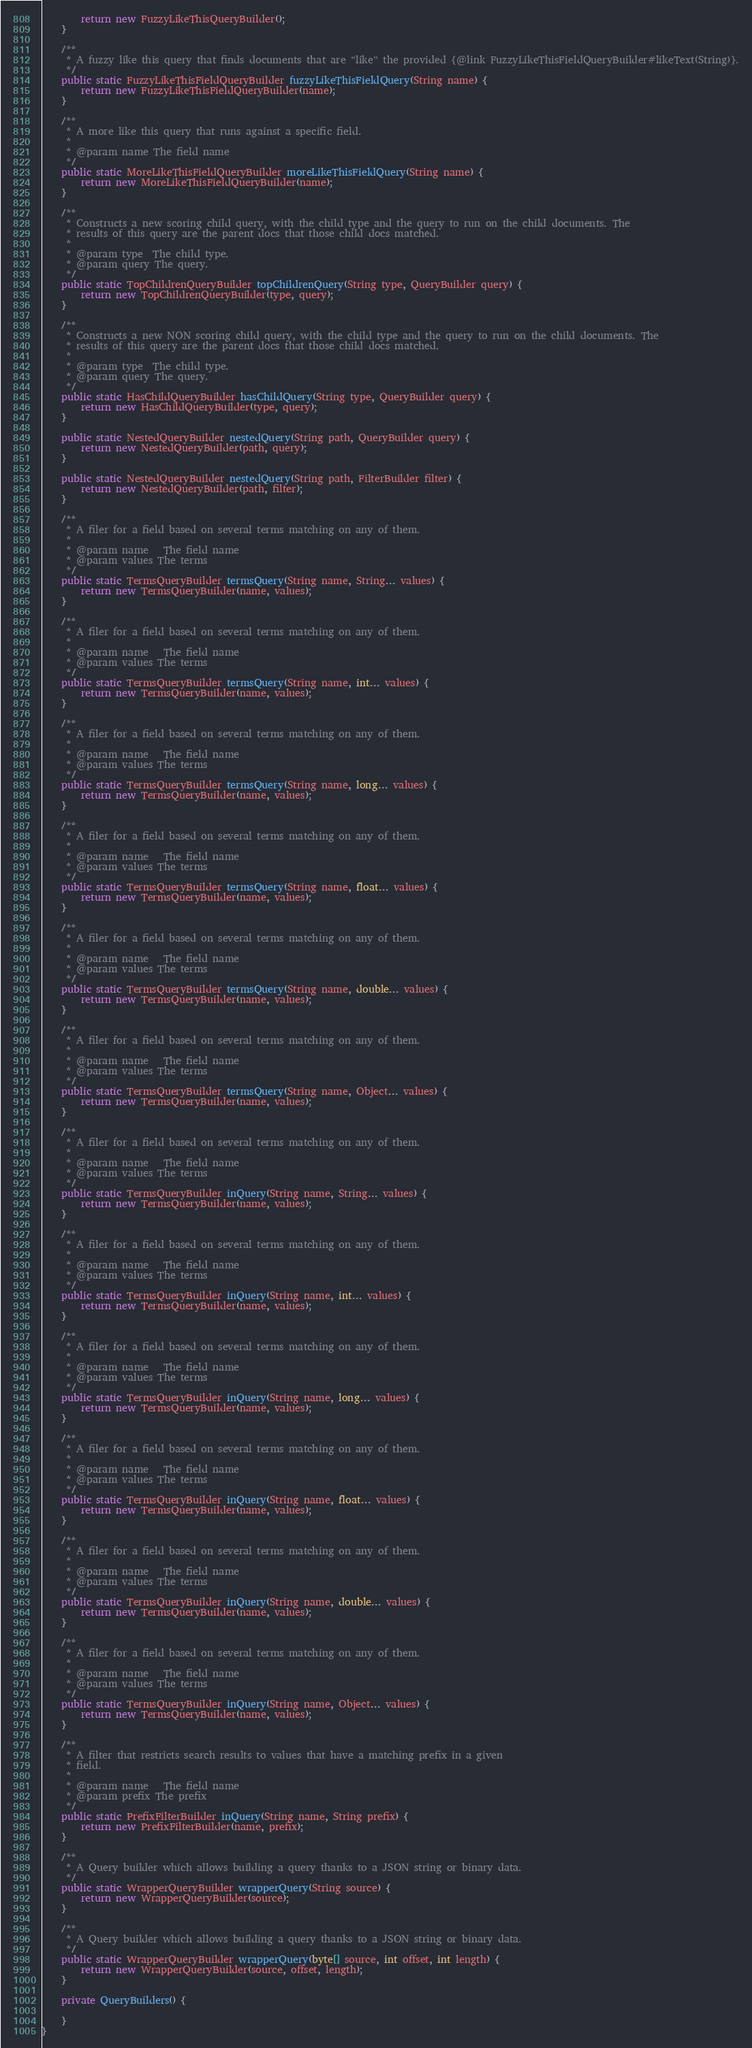<code> <loc_0><loc_0><loc_500><loc_500><_Java_>        return new FuzzyLikeThisQueryBuilder();
    }

    /**
     * A fuzzy like this query that finds documents that are "like" the provided {@link FuzzyLikeThisFieldQueryBuilder#likeText(String)}.
     */
    public static FuzzyLikeThisFieldQueryBuilder fuzzyLikeThisFieldQuery(String name) {
        return new FuzzyLikeThisFieldQueryBuilder(name);
    }

    /**
     * A more like this query that runs against a specific field.
     *
     * @param name The field name
     */
    public static MoreLikeThisFieldQueryBuilder moreLikeThisFieldQuery(String name) {
        return new MoreLikeThisFieldQueryBuilder(name);
    }

    /**
     * Constructs a new scoring child query, with the child type and the query to run on the child documents. The
     * results of this query are the parent docs that those child docs matched.
     *
     * @param type  The child type.
     * @param query The query.
     */
    public static TopChildrenQueryBuilder topChildrenQuery(String type, QueryBuilder query) {
        return new TopChildrenQueryBuilder(type, query);
    }

    /**
     * Constructs a new NON scoring child query, with the child type and the query to run on the child documents. The
     * results of this query are the parent docs that those child docs matched.
     *
     * @param type  The child type.
     * @param query The query.
     */
    public static HasChildQueryBuilder hasChildQuery(String type, QueryBuilder query) {
        return new HasChildQueryBuilder(type, query);
    }

    public static NestedQueryBuilder nestedQuery(String path, QueryBuilder query) {
        return new NestedQueryBuilder(path, query);
    }

    public static NestedQueryBuilder nestedQuery(String path, FilterBuilder filter) {
        return new NestedQueryBuilder(path, filter);
    }

    /**
     * A filer for a field based on several terms matching on any of them.
     *
     * @param name   The field name
     * @param values The terms
     */
    public static TermsQueryBuilder termsQuery(String name, String... values) {
        return new TermsQueryBuilder(name, values);
    }

    /**
     * A filer for a field based on several terms matching on any of them.
     *
     * @param name   The field name
     * @param values The terms
     */
    public static TermsQueryBuilder termsQuery(String name, int... values) {
        return new TermsQueryBuilder(name, values);
    }

    /**
     * A filer for a field based on several terms matching on any of them.
     *
     * @param name   The field name
     * @param values The terms
     */
    public static TermsQueryBuilder termsQuery(String name, long... values) {
        return new TermsQueryBuilder(name, values);
    }

    /**
     * A filer for a field based on several terms matching on any of them.
     *
     * @param name   The field name
     * @param values The terms
     */
    public static TermsQueryBuilder termsQuery(String name, float... values) {
        return new TermsQueryBuilder(name, values);
    }

    /**
     * A filer for a field based on several terms matching on any of them.
     *
     * @param name   The field name
     * @param values The terms
     */
    public static TermsQueryBuilder termsQuery(String name, double... values) {
        return new TermsQueryBuilder(name, values);
    }

    /**
     * A filer for a field based on several terms matching on any of them.
     *
     * @param name   The field name
     * @param values The terms
     */
    public static TermsQueryBuilder termsQuery(String name, Object... values) {
        return new TermsQueryBuilder(name, values);
    }

    /**
     * A filer for a field based on several terms matching on any of them.
     *
     * @param name   The field name
     * @param values The terms
     */
    public static TermsQueryBuilder inQuery(String name, String... values) {
        return new TermsQueryBuilder(name, values);
    }

    /**
     * A filer for a field based on several terms matching on any of them.
     *
     * @param name   The field name
     * @param values The terms
     */
    public static TermsQueryBuilder inQuery(String name, int... values) {
        return new TermsQueryBuilder(name, values);
    }

    /**
     * A filer for a field based on several terms matching on any of them.
     *
     * @param name   The field name
     * @param values The terms
     */
    public static TermsQueryBuilder inQuery(String name, long... values) {
        return new TermsQueryBuilder(name, values);
    }

    /**
     * A filer for a field based on several terms matching on any of them.
     *
     * @param name   The field name
     * @param values The terms
     */
    public static TermsQueryBuilder inQuery(String name, float... values) {
        return new TermsQueryBuilder(name, values);
    }

    /**
     * A filer for a field based on several terms matching on any of them.
     *
     * @param name   The field name
     * @param values The terms
     */
    public static TermsQueryBuilder inQuery(String name, double... values) {
        return new TermsQueryBuilder(name, values);
    }

    /**
     * A filer for a field based on several terms matching on any of them.
     *
     * @param name   The field name
     * @param values The terms
     */
    public static TermsQueryBuilder inQuery(String name, Object... values) {
        return new TermsQueryBuilder(name, values);
    }

    /**
     * A filter that restricts search results to values that have a matching prefix in a given
     * field.
     *
     * @param name   The field name
     * @param prefix The prefix
     */
    public static PrefixFilterBuilder inQuery(String name, String prefix) {
        return new PrefixFilterBuilder(name, prefix);
    }

    /**
     * A Query builder which allows building a query thanks to a JSON string or binary data.
     */
    public static WrapperQueryBuilder wrapperQuery(String source) {
        return new WrapperQueryBuilder(source);
    }

    /**
     * A Query builder which allows building a query thanks to a JSON string or binary data.
     */
    public static WrapperQueryBuilder wrapperQuery(byte[] source, int offset, int length) {
        return new WrapperQueryBuilder(source, offset, length);
    }

    private QueryBuilders() {

    }
}
</code> 